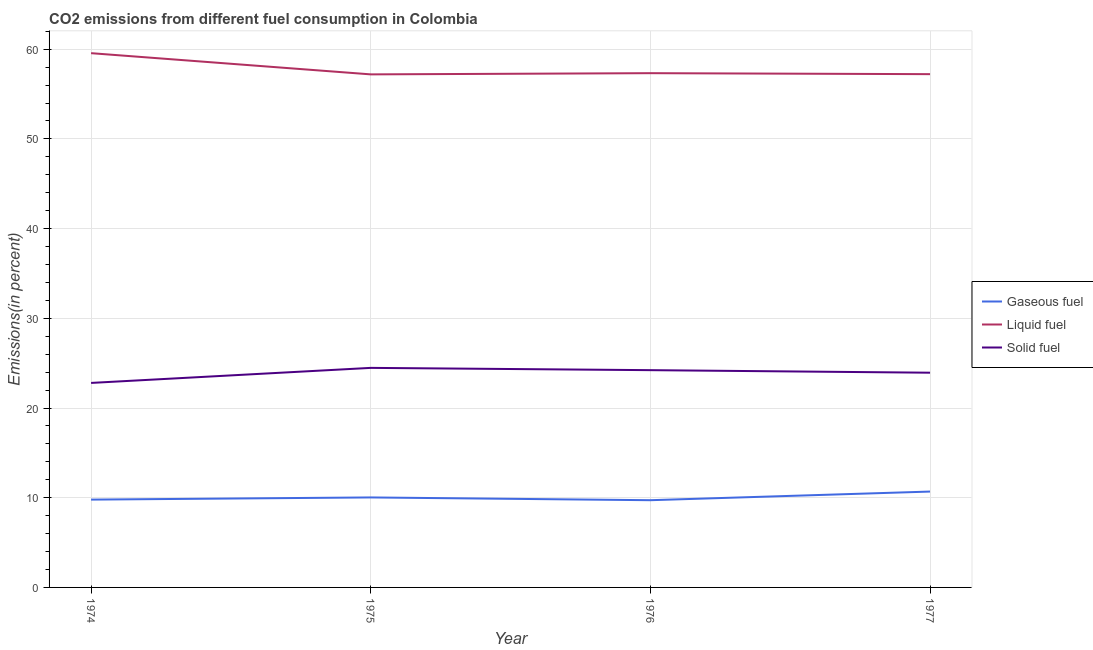How many different coloured lines are there?
Your answer should be very brief. 3. Does the line corresponding to percentage of solid fuel emission intersect with the line corresponding to percentage of liquid fuel emission?
Offer a terse response. No. What is the percentage of liquid fuel emission in 1974?
Your answer should be very brief. 59.56. Across all years, what is the maximum percentage of solid fuel emission?
Provide a succinct answer. 24.48. Across all years, what is the minimum percentage of liquid fuel emission?
Keep it short and to the point. 57.2. In which year was the percentage of solid fuel emission maximum?
Ensure brevity in your answer.  1975. In which year was the percentage of gaseous fuel emission minimum?
Your response must be concise. 1976. What is the total percentage of solid fuel emission in the graph?
Ensure brevity in your answer.  95.44. What is the difference between the percentage of liquid fuel emission in 1974 and that in 1975?
Give a very brief answer. 2.36. What is the difference between the percentage of gaseous fuel emission in 1975 and the percentage of liquid fuel emission in 1976?
Make the answer very short. -47.3. What is the average percentage of liquid fuel emission per year?
Your response must be concise. 57.83. In the year 1977, what is the difference between the percentage of gaseous fuel emission and percentage of liquid fuel emission?
Make the answer very short. -46.53. What is the ratio of the percentage of solid fuel emission in 1975 to that in 1977?
Offer a very short reply. 1.02. What is the difference between the highest and the second highest percentage of liquid fuel emission?
Give a very brief answer. 2.23. What is the difference between the highest and the lowest percentage of gaseous fuel emission?
Give a very brief answer. 0.96. In how many years, is the percentage of gaseous fuel emission greater than the average percentage of gaseous fuel emission taken over all years?
Make the answer very short. 1. Is the sum of the percentage of gaseous fuel emission in 1976 and 1977 greater than the maximum percentage of liquid fuel emission across all years?
Offer a terse response. No. Is it the case that in every year, the sum of the percentage of gaseous fuel emission and percentage of liquid fuel emission is greater than the percentage of solid fuel emission?
Offer a very short reply. Yes. Does the percentage of liquid fuel emission monotonically increase over the years?
Your answer should be compact. No. Is the percentage of liquid fuel emission strictly less than the percentage of gaseous fuel emission over the years?
Your answer should be very brief. No. How many lines are there?
Offer a very short reply. 3. How many years are there in the graph?
Your answer should be compact. 4. Are the values on the major ticks of Y-axis written in scientific E-notation?
Make the answer very short. No. Where does the legend appear in the graph?
Provide a succinct answer. Center right. How many legend labels are there?
Your answer should be very brief. 3. What is the title of the graph?
Your answer should be very brief. CO2 emissions from different fuel consumption in Colombia. What is the label or title of the Y-axis?
Your answer should be compact. Emissions(in percent). What is the Emissions(in percent) of Gaseous fuel in 1974?
Keep it short and to the point. 9.79. What is the Emissions(in percent) in Liquid fuel in 1974?
Your answer should be very brief. 59.56. What is the Emissions(in percent) of Solid fuel in 1974?
Give a very brief answer. 22.8. What is the Emissions(in percent) in Gaseous fuel in 1975?
Give a very brief answer. 10.03. What is the Emissions(in percent) in Liquid fuel in 1975?
Give a very brief answer. 57.2. What is the Emissions(in percent) of Solid fuel in 1975?
Give a very brief answer. 24.48. What is the Emissions(in percent) in Gaseous fuel in 1976?
Your answer should be compact. 9.72. What is the Emissions(in percent) in Liquid fuel in 1976?
Provide a succinct answer. 57.33. What is the Emissions(in percent) of Solid fuel in 1976?
Offer a terse response. 24.22. What is the Emissions(in percent) of Gaseous fuel in 1977?
Make the answer very short. 10.69. What is the Emissions(in percent) of Liquid fuel in 1977?
Give a very brief answer. 57.22. What is the Emissions(in percent) of Solid fuel in 1977?
Make the answer very short. 23.94. Across all years, what is the maximum Emissions(in percent) of Gaseous fuel?
Make the answer very short. 10.69. Across all years, what is the maximum Emissions(in percent) in Liquid fuel?
Your answer should be very brief. 59.56. Across all years, what is the maximum Emissions(in percent) in Solid fuel?
Ensure brevity in your answer.  24.48. Across all years, what is the minimum Emissions(in percent) of Gaseous fuel?
Offer a very short reply. 9.72. Across all years, what is the minimum Emissions(in percent) of Liquid fuel?
Offer a very short reply. 57.2. Across all years, what is the minimum Emissions(in percent) of Solid fuel?
Provide a succinct answer. 22.8. What is the total Emissions(in percent) of Gaseous fuel in the graph?
Provide a succinct answer. 40.23. What is the total Emissions(in percent) of Liquid fuel in the graph?
Make the answer very short. 231.31. What is the total Emissions(in percent) of Solid fuel in the graph?
Keep it short and to the point. 95.44. What is the difference between the Emissions(in percent) of Gaseous fuel in 1974 and that in 1975?
Offer a terse response. -0.24. What is the difference between the Emissions(in percent) of Liquid fuel in 1974 and that in 1975?
Make the answer very short. 2.36. What is the difference between the Emissions(in percent) in Solid fuel in 1974 and that in 1975?
Make the answer very short. -1.68. What is the difference between the Emissions(in percent) in Gaseous fuel in 1974 and that in 1976?
Your response must be concise. 0.07. What is the difference between the Emissions(in percent) in Liquid fuel in 1974 and that in 1976?
Your answer should be compact. 2.23. What is the difference between the Emissions(in percent) in Solid fuel in 1974 and that in 1976?
Ensure brevity in your answer.  -1.42. What is the difference between the Emissions(in percent) in Gaseous fuel in 1974 and that in 1977?
Your answer should be very brief. -0.9. What is the difference between the Emissions(in percent) in Liquid fuel in 1974 and that in 1977?
Provide a short and direct response. 2.34. What is the difference between the Emissions(in percent) of Solid fuel in 1974 and that in 1977?
Offer a very short reply. -1.14. What is the difference between the Emissions(in percent) in Gaseous fuel in 1975 and that in 1976?
Provide a succinct answer. 0.31. What is the difference between the Emissions(in percent) of Liquid fuel in 1975 and that in 1976?
Your answer should be very brief. -0.13. What is the difference between the Emissions(in percent) in Solid fuel in 1975 and that in 1976?
Your answer should be very brief. 0.25. What is the difference between the Emissions(in percent) of Gaseous fuel in 1975 and that in 1977?
Offer a terse response. -0.66. What is the difference between the Emissions(in percent) in Liquid fuel in 1975 and that in 1977?
Your answer should be very brief. -0.02. What is the difference between the Emissions(in percent) in Solid fuel in 1975 and that in 1977?
Keep it short and to the point. 0.54. What is the difference between the Emissions(in percent) in Gaseous fuel in 1976 and that in 1977?
Ensure brevity in your answer.  -0.96. What is the difference between the Emissions(in percent) of Liquid fuel in 1976 and that in 1977?
Keep it short and to the point. 0.11. What is the difference between the Emissions(in percent) of Solid fuel in 1976 and that in 1977?
Offer a very short reply. 0.28. What is the difference between the Emissions(in percent) of Gaseous fuel in 1974 and the Emissions(in percent) of Liquid fuel in 1975?
Your answer should be very brief. -47.41. What is the difference between the Emissions(in percent) in Gaseous fuel in 1974 and the Emissions(in percent) in Solid fuel in 1975?
Provide a succinct answer. -14.69. What is the difference between the Emissions(in percent) in Liquid fuel in 1974 and the Emissions(in percent) in Solid fuel in 1975?
Keep it short and to the point. 35.08. What is the difference between the Emissions(in percent) of Gaseous fuel in 1974 and the Emissions(in percent) of Liquid fuel in 1976?
Your answer should be compact. -47.54. What is the difference between the Emissions(in percent) of Gaseous fuel in 1974 and the Emissions(in percent) of Solid fuel in 1976?
Give a very brief answer. -14.43. What is the difference between the Emissions(in percent) of Liquid fuel in 1974 and the Emissions(in percent) of Solid fuel in 1976?
Provide a succinct answer. 35.34. What is the difference between the Emissions(in percent) of Gaseous fuel in 1974 and the Emissions(in percent) of Liquid fuel in 1977?
Ensure brevity in your answer.  -47.43. What is the difference between the Emissions(in percent) of Gaseous fuel in 1974 and the Emissions(in percent) of Solid fuel in 1977?
Offer a very short reply. -14.15. What is the difference between the Emissions(in percent) in Liquid fuel in 1974 and the Emissions(in percent) in Solid fuel in 1977?
Give a very brief answer. 35.62. What is the difference between the Emissions(in percent) in Gaseous fuel in 1975 and the Emissions(in percent) in Liquid fuel in 1976?
Offer a very short reply. -47.3. What is the difference between the Emissions(in percent) of Gaseous fuel in 1975 and the Emissions(in percent) of Solid fuel in 1976?
Offer a very short reply. -14.19. What is the difference between the Emissions(in percent) in Liquid fuel in 1975 and the Emissions(in percent) in Solid fuel in 1976?
Keep it short and to the point. 32.97. What is the difference between the Emissions(in percent) in Gaseous fuel in 1975 and the Emissions(in percent) in Liquid fuel in 1977?
Offer a terse response. -47.19. What is the difference between the Emissions(in percent) in Gaseous fuel in 1975 and the Emissions(in percent) in Solid fuel in 1977?
Offer a terse response. -13.91. What is the difference between the Emissions(in percent) in Liquid fuel in 1975 and the Emissions(in percent) in Solid fuel in 1977?
Provide a succinct answer. 33.26. What is the difference between the Emissions(in percent) in Gaseous fuel in 1976 and the Emissions(in percent) in Liquid fuel in 1977?
Your response must be concise. -47.5. What is the difference between the Emissions(in percent) of Gaseous fuel in 1976 and the Emissions(in percent) of Solid fuel in 1977?
Offer a terse response. -14.21. What is the difference between the Emissions(in percent) of Liquid fuel in 1976 and the Emissions(in percent) of Solid fuel in 1977?
Offer a very short reply. 33.39. What is the average Emissions(in percent) in Gaseous fuel per year?
Your answer should be compact. 10.06. What is the average Emissions(in percent) in Liquid fuel per year?
Your answer should be compact. 57.83. What is the average Emissions(in percent) in Solid fuel per year?
Provide a succinct answer. 23.86. In the year 1974, what is the difference between the Emissions(in percent) of Gaseous fuel and Emissions(in percent) of Liquid fuel?
Provide a succinct answer. -49.77. In the year 1974, what is the difference between the Emissions(in percent) of Gaseous fuel and Emissions(in percent) of Solid fuel?
Offer a terse response. -13.01. In the year 1974, what is the difference between the Emissions(in percent) in Liquid fuel and Emissions(in percent) in Solid fuel?
Offer a terse response. 36.76. In the year 1975, what is the difference between the Emissions(in percent) of Gaseous fuel and Emissions(in percent) of Liquid fuel?
Your answer should be very brief. -47.17. In the year 1975, what is the difference between the Emissions(in percent) in Gaseous fuel and Emissions(in percent) in Solid fuel?
Offer a very short reply. -14.44. In the year 1975, what is the difference between the Emissions(in percent) of Liquid fuel and Emissions(in percent) of Solid fuel?
Ensure brevity in your answer.  32.72. In the year 1976, what is the difference between the Emissions(in percent) of Gaseous fuel and Emissions(in percent) of Liquid fuel?
Provide a succinct answer. -47.61. In the year 1976, what is the difference between the Emissions(in percent) of Gaseous fuel and Emissions(in percent) of Solid fuel?
Give a very brief answer. -14.5. In the year 1976, what is the difference between the Emissions(in percent) of Liquid fuel and Emissions(in percent) of Solid fuel?
Give a very brief answer. 33.11. In the year 1977, what is the difference between the Emissions(in percent) in Gaseous fuel and Emissions(in percent) in Liquid fuel?
Make the answer very short. -46.53. In the year 1977, what is the difference between the Emissions(in percent) in Gaseous fuel and Emissions(in percent) in Solid fuel?
Your answer should be compact. -13.25. In the year 1977, what is the difference between the Emissions(in percent) of Liquid fuel and Emissions(in percent) of Solid fuel?
Make the answer very short. 33.28. What is the ratio of the Emissions(in percent) in Gaseous fuel in 1974 to that in 1975?
Make the answer very short. 0.98. What is the ratio of the Emissions(in percent) in Liquid fuel in 1974 to that in 1975?
Your answer should be very brief. 1.04. What is the ratio of the Emissions(in percent) in Solid fuel in 1974 to that in 1975?
Make the answer very short. 0.93. What is the ratio of the Emissions(in percent) in Gaseous fuel in 1974 to that in 1976?
Your response must be concise. 1.01. What is the ratio of the Emissions(in percent) in Liquid fuel in 1974 to that in 1976?
Provide a succinct answer. 1.04. What is the ratio of the Emissions(in percent) in Solid fuel in 1974 to that in 1976?
Offer a very short reply. 0.94. What is the ratio of the Emissions(in percent) of Gaseous fuel in 1974 to that in 1977?
Offer a terse response. 0.92. What is the ratio of the Emissions(in percent) in Liquid fuel in 1974 to that in 1977?
Keep it short and to the point. 1.04. What is the ratio of the Emissions(in percent) of Gaseous fuel in 1975 to that in 1976?
Offer a very short reply. 1.03. What is the ratio of the Emissions(in percent) in Solid fuel in 1975 to that in 1976?
Your response must be concise. 1.01. What is the ratio of the Emissions(in percent) of Gaseous fuel in 1975 to that in 1977?
Your answer should be compact. 0.94. What is the ratio of the Emissions(in percent) in Liquid fuel in 1975 to that in 1977?
Make the answer very short. 1. What is the ratio of the Emissions(in percent) of Solid fuel in 1975 to that in 1977?
Offer a very short reply. 1.02. What is the ratio of the Emissions(in percent) in Gaseous fuel in 1976 to that in 1977?
Make the answer very short. 0.91. What is the ratio of the Emissions(in percent) in Liquid fuel in 1976 to that in 1977?
Your answer should be compact. 1. What is the ratio of the Emissions(in percent) in Solid fuel in 1976 to that in 1977?
Make the answer very short. 1.01. What is the difference between the highest and the second highest Emissions(in percent) of Gaseous fuel?
Your response must be concise. 0.66. What is the difference between the highest and the second highest Emissions(in percent) in Liquid fuel?
Your answer should be very brief. 2.23. What is the difference between the highest and the second highest Emissions(in percent) in Solid fuel?
Provide a short and direct response. 0.25. What is the difference between the highest and the lowest Emissions(in percent) of Liquid fuel?
Offer a terse response. 2.36. What is the difference between the highest and the lowest Emissions(in percent) in Solid fuel?
Give a very brief answer. 1.68. 